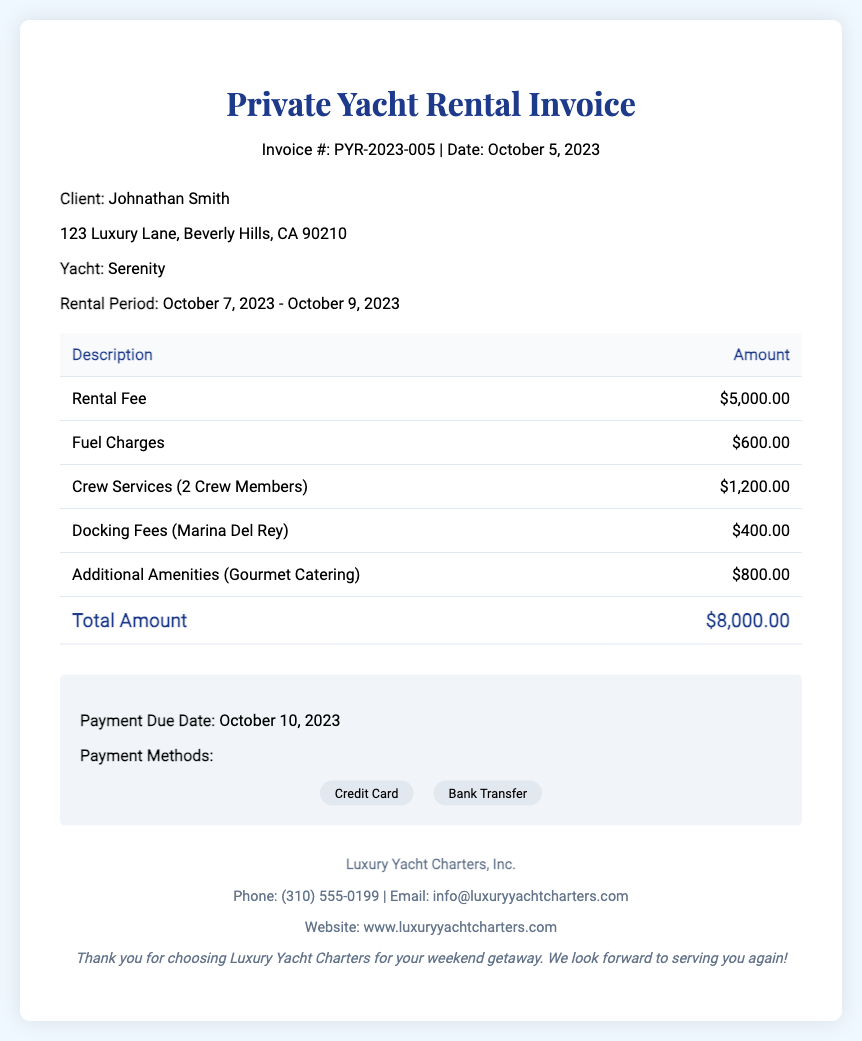What is the invoice number? The invoice number is clearly stated at the top of the document, which is PYR-2023-005.
Answer: PYR-2023-005 What is the total amount due? The total amount due is specified in the table under the "Total Amount" row, which sums the rental fee, fuel, crew services, docking fees, and additional amenities.
Answer: $8,000.00 Who is the client? The client's name is mentioned in the client info section, which is Johnathan Smith.
Answer: Johnathan Smith What is the rental period? The rental period is detailed in the client info section, encompassing the dates from October 7, 2023, to October 9, 2023.
Answer: October 7, 2023 - October 9, 2023 How much are the fuel charges? The fuel charges are listed in the invoice table, under the description "Fuel Charges."
Answer: $600.00 How many crew members are included in the services? The invoice mentions "2 Crew Members" under the description of crew services.
Answer: 2 Crew Members What is the payment due date? The payment due date is specified in the summary section of the document, which is October 10, 2023.
Answer: October 10, 2023 What are the payment methods mentioned? The payment methods are listed in the summary section, and they include "Credit Card" and "Bank Transfer."
Answer: Credit Card, Bank Transfer What additional amenity is included in the invoice? The additional amenity specified in the invoice is "Gourmet Catering."
Answer: Gourmet Catering 